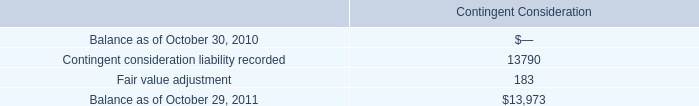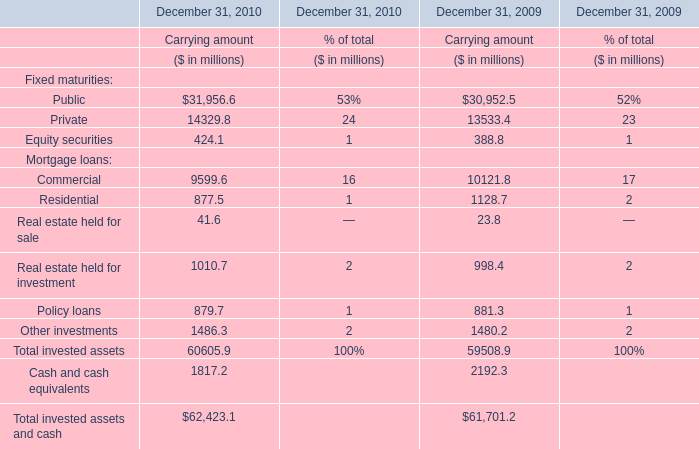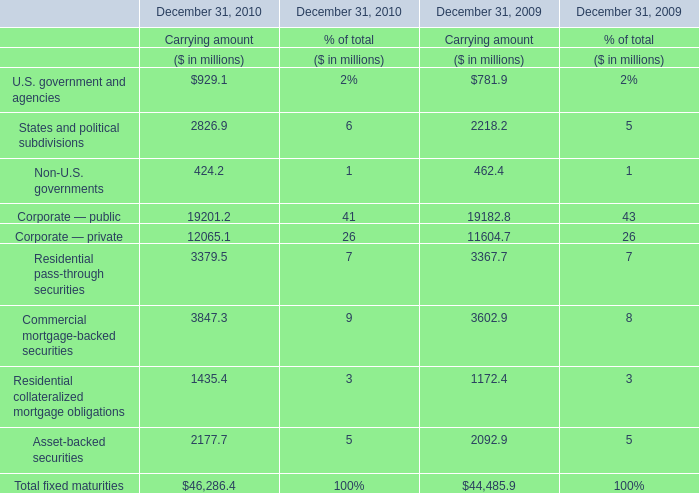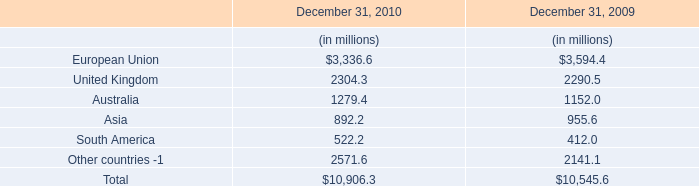What was the total amount of elements in 2010? (in million) 
Computations: (60605.9 + 1817.2)
Answer: 62423.1. 